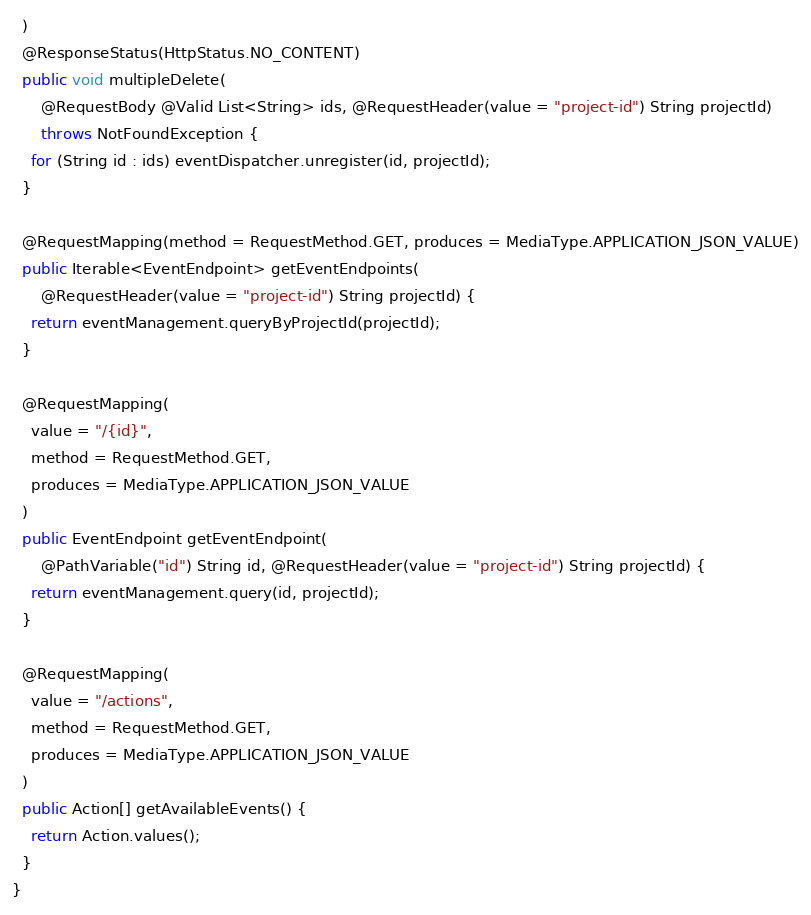Convert code to text. <code><loc_0><loc_0><loc_500><loc_500><_Java_>  )
  @ResponseStatus(HttpStatus.NO_CONTENT)
  public void multipleDelete(
      @RequestBody @Valid List<String> ids, @RequestHeader(value = "project-id") String projectId)
      throws NotFoundException {
    for (String id : ids) eventDispatcher.unregister(id, projectId);
  }

  @RequestMapping(method = RequestMethod.GET, produces = MediaType.APPLICATION_JSON_VALUE)
  public Iterable<EventEndpoint> getEventEndpoints(
      @RequestHeader(value = "project-id") String projectId) {
    return eventManagement.queryByProjectId(projectId);
  }

  @RequestMapping(
    value = "/{id}",
    method = RequestMethod.GET,
    produces = MediaType.APPLICATION_JSON_VALUE
  )
  public EventEndpoint getEventEndpoint(
      @PathVariable("id") String id, @RequestHeader(value = "project-id") String projectId) {
    return eventManagement.query(id, projectId);
  }

  @RequestMapping(
    value = "/actions",
    method = RequestMethod.GET,
    produces = MediaType.APPLICATION_JSON_VALUE
  )
  public Action[] getAvailableEvents() {
    return Action.values();
  }
}
</code> 